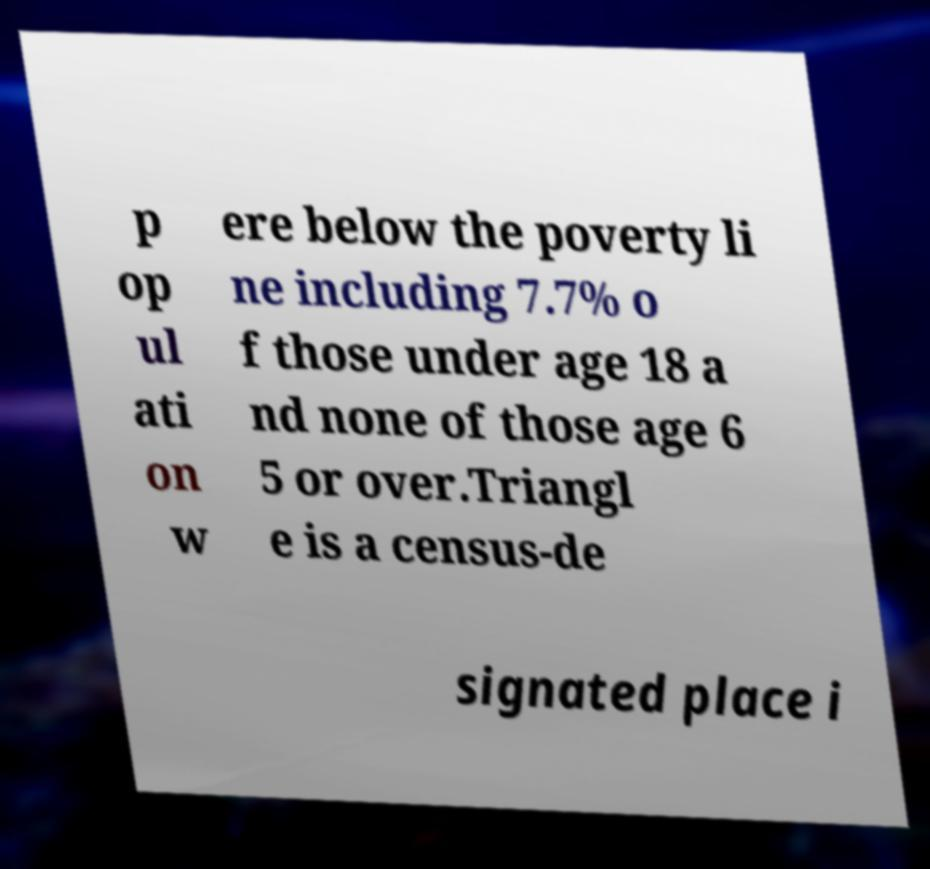Please identify and transcribe the text found in this image. p op ul ati on w ere below the poverty li ne including 7.7% o f those under age 18 a nd none of those age 6 5 or over.Triangl e is a census-de signated place i 